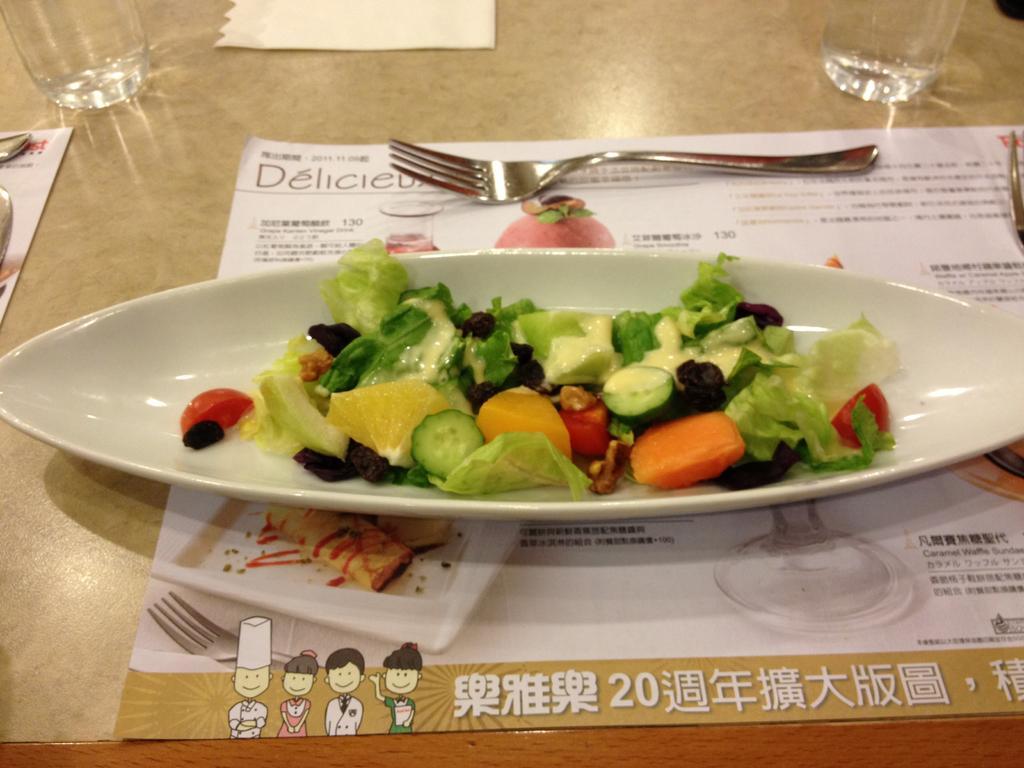In one or two sentences, can you explain what this image depicts? In the image we can see there is a salad dish kept in the plate and the plate is kept on the menu card on the table. There is fork, glasses and tissue paper kept on the table. 